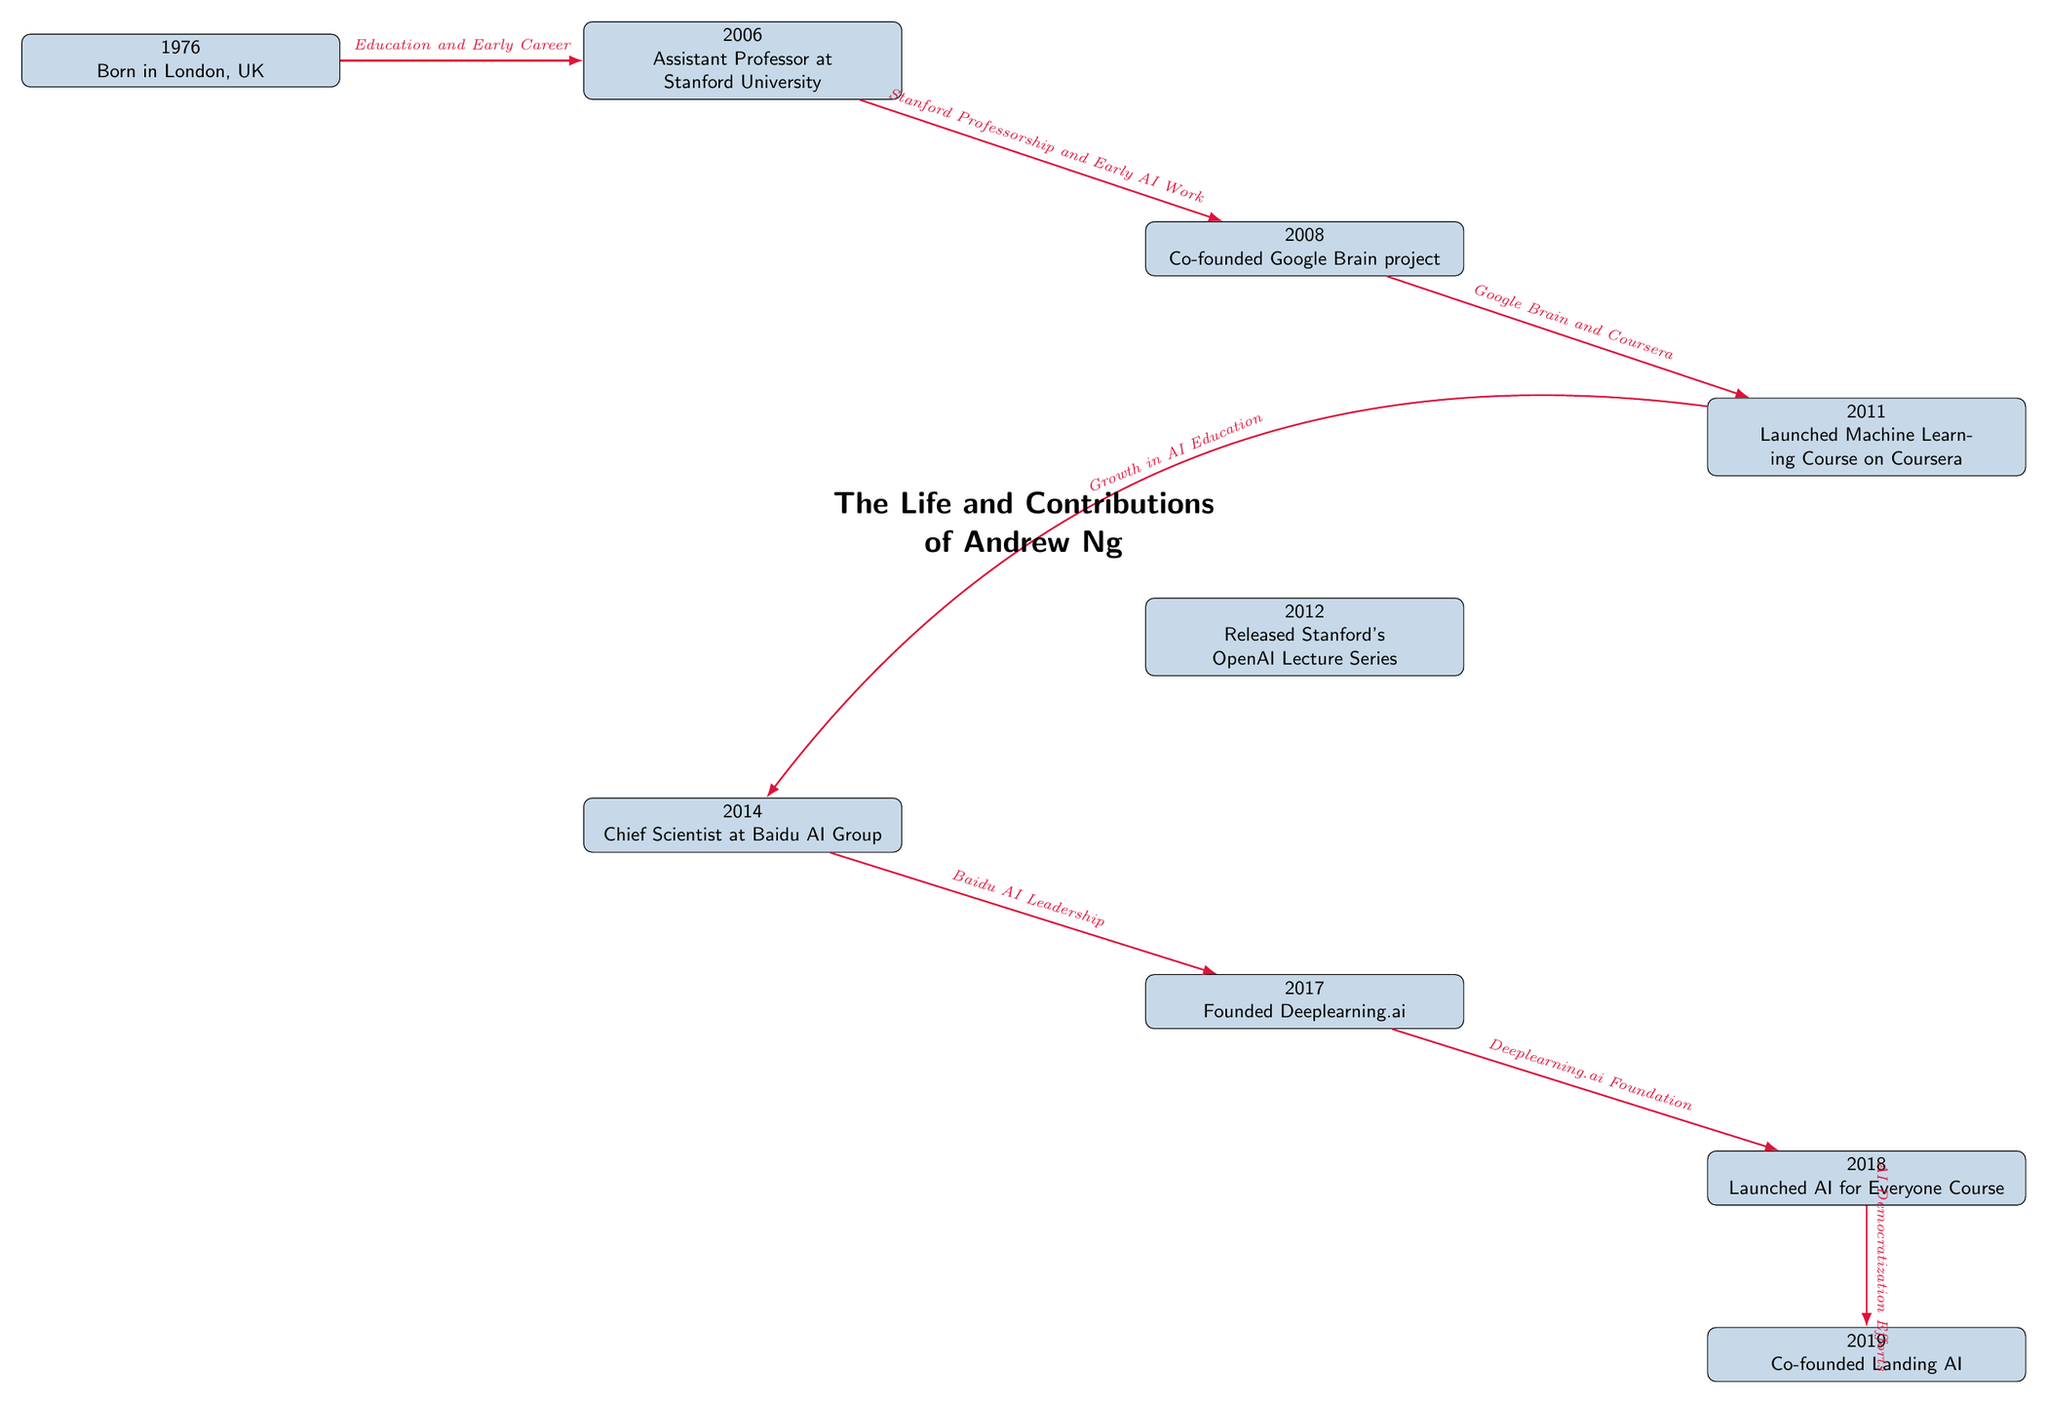What year was Andrew Ng born? The diagram indicates that Andrew Ng was born in 1976, as this information is presented in the first node of the timeline.
Answer: 1976 What significant project did Andrew Ng co-found in 2008? The diagram shows that in 2008, he co-founded the Google Brain project, which is noted next to the corresponding milestone.
Answer: Google Brain project How many key milestones are listed in the diagram? By counting the events in the timeline from 1976 to 2019, there are a total of 9 key milestones, each represented as a node in the diagram.
Answer: 9 What was Andrew Ng's role at Baidu in 2014? In the diagram, it states that Andrew Ng was the Chief Scientist at Baidu AI Group in 2014, located under that year’s milestone.
Answer: Chief Scientist Which course did he launch in 2018? The timeline specifies that in 2018, he launched the "AI for Everyone" course, as indicated in the corresponding node on the diagram.
Answer: AI for Everyone Course What relationship exists between the milestones of 2011 and 2014? The diagram illustrates that the 2011 milestone regarding the Machine Learning Course on Coursera leads to the 2014 milestone through the description stating "Growth in AI Education," highlighting continuous development in the education sector.
Answer: Growth in AI Education During which year did Andrew Ng found deeplearning.ai? Referring to the timeline, the milestone of founding deeplearning.ai is represented in 2017.
Answer: 2017 What event is noted directly after the launch of the AI for Everyone course? The diagram indicates that the event following the AI for Everyone course is the co-founding of Landing AI in 2019, which follows in the timeline.
Answer: Co-founded Landing AI What is the main theme of the diagram? The central title at the top of the diagram specifies that it covers "The Life and Contributions of Andrew Ng," providing a clear overview of the focus of the content.
Answer: The Life and Contributions of Andrew Ng 